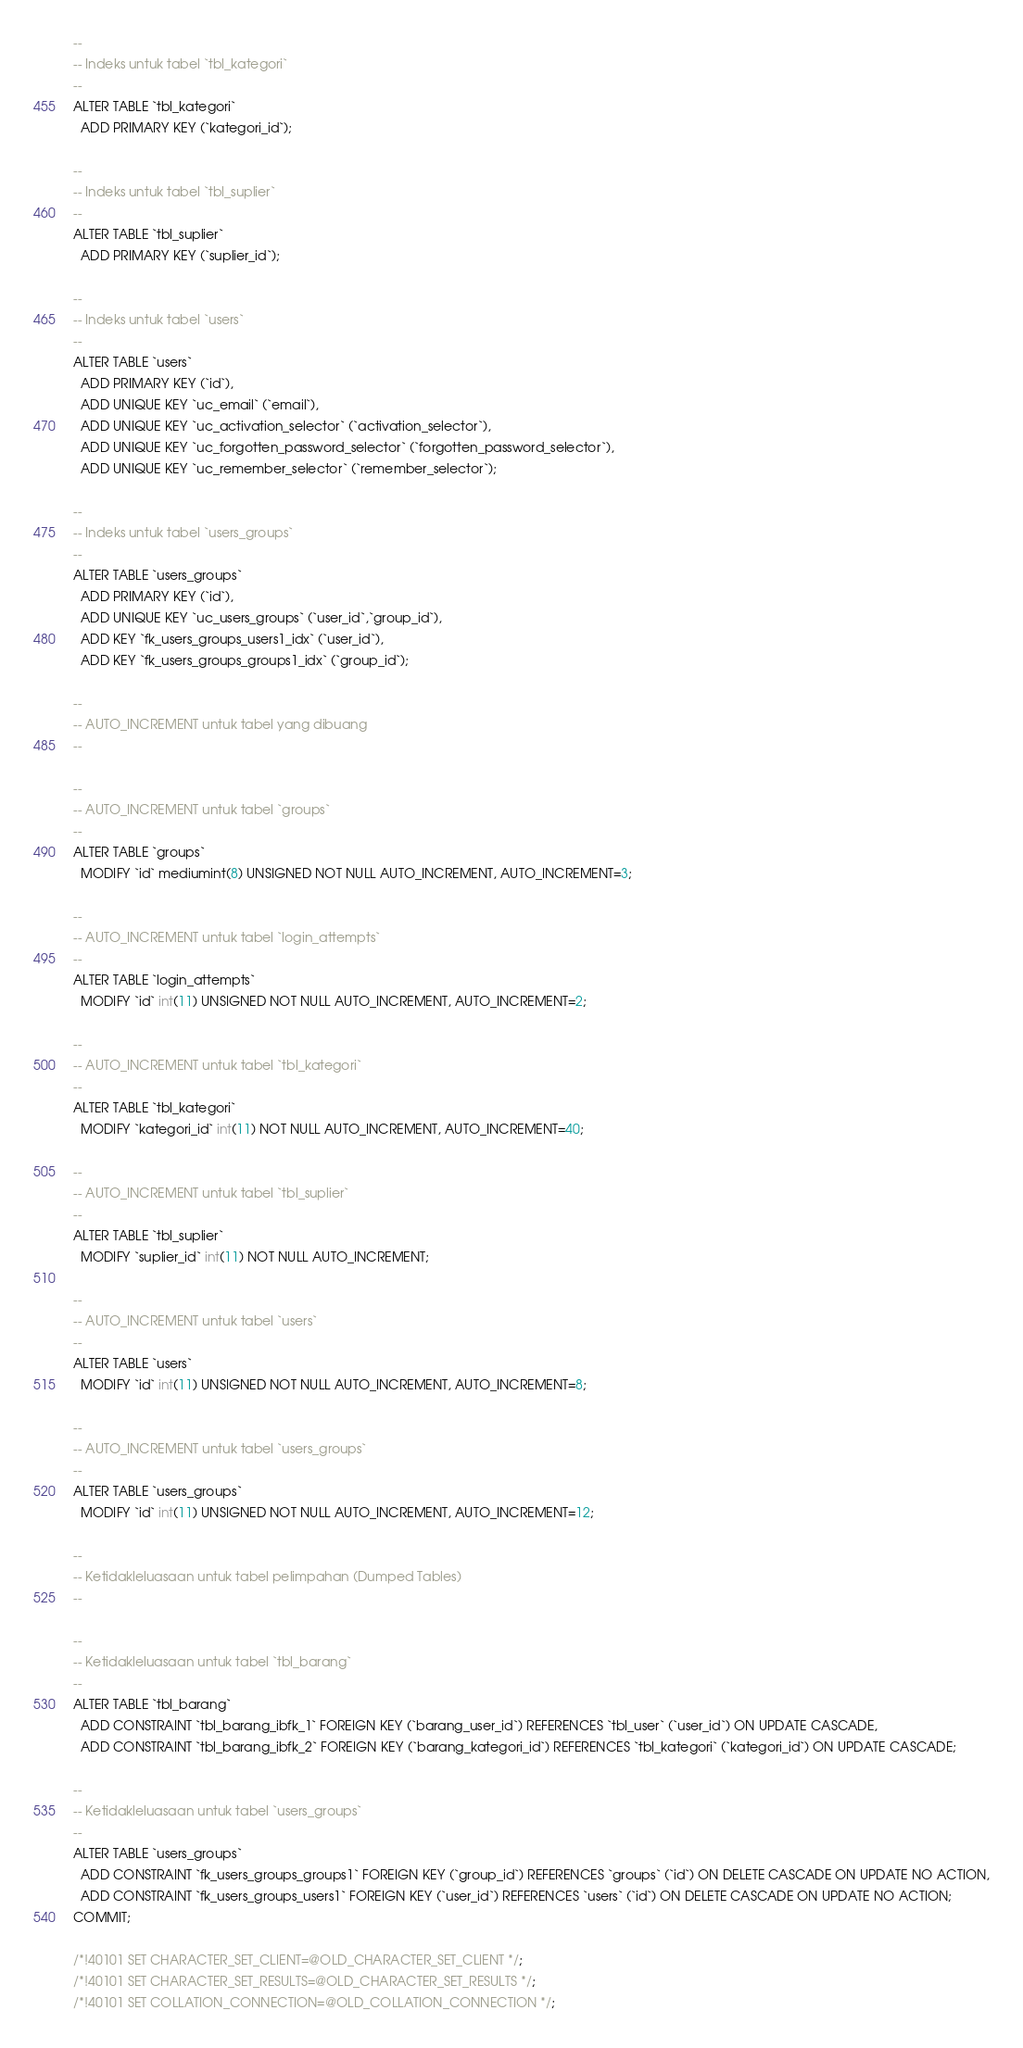Convert code to text. <code><loc_0><loc_0><loc_500><loc_500><_SQL_>
--
-- Indeks untuk tabel `tbl_kategori`
--
ALTER TABLE `tbl_kategori`
  ADD PRIMARY KEY (`kategori_id`);

--
-- Indeks untuk tabel `tbl_suplier`
--
ALTER TABLE `tbl_suplier`
  ADD PRIMARY KEY (`suplier_id`);

--
-- Indeks untuk tabel `users`
--
ALTER TABLE `users`
  ADD PRIMARY KEY (`id`),
  ADD UNIQUE KEY `uc_email` (`email`),
  ADD UNIQUE KEY `uc_activation_selector` (`activation_selector`),
  ADD UNIQUE KEY `uc_forgotten_password_selector` (`forgotten_password_selector`),
  ADD UNIQUE KEY `uc_remember_selector` (`remember_selector`);

--
-- Indeks untuk tabel `users_groups`
--
ALTER TABLE `users_groups`
  ADD PRIMARY KEY (`id`),
  ADD UNIQUE KEY `uc_users_groups` (`user_id`,`group_id`),
  ADD KEY `fk_users_groups_users1_idx` (`user_id`),
  ADD KEY `fk_users_groups_groups1_idx` (`group_id`);

--
-- AUTO_INCREMENT untuk tabel yang dibuang
--

--
-- AUTO_INCREMENT untuk tabel `groups`
--
ALTER TABLE `groups`
  MODIFY `id` mediumint(8) UNSIGNED NOT NULL AUTO_INCREMENT, AUTO_INCREMENT=3;

--
-- AUTO_INCREMENT untuk tabel `login_attempts`
--
ALTER TABLE `login_attempts`
  MODIFY `id` int(11) UNSIGNED NOT NULL AUTO_INCREMENT, AUTO_INCREMENT=2;

--
-- AUTO_INCREMENT untuk tabel `tbl_kategori`
--
ALTER TABLE `tbl_kategori`
  MODIFY `kategori_id` int(11) NOT NULL AUTO_INCREMENT, AUTO_INCREMENT=40;

--
-- AUTO_INCREMENT untuk tabel `tbl_suplier`
--
ALTER TABLE `tbl_suplier`
  MODIFY `suplier_id` int(11) NOT NULL AUTO_INCREMENT;

--
-- AUTO_INCREMENT untuk tabel `users`
--
ALTER TABLE `users`
  MODIFY `id` int(11) UNSIGNED NOT NULL AUTO_INCREMENT, AUTO_INCREMENT=8;

--
-- AUTO_INCREMENT untuk tabel `users_groups`
--
ALTER TABLE `users_groups`
  MODIFY `id` int(11) UNSIGNED NOT NULL AUTO_INCREMENT, AUTO_INCREMENT=12;

--
-- Ketidakleluasaan untuk tabel pelimpahan (Dumped Tables)
--

--
-- Ketidakleluasaan untuk tabel `tbl_barang`
--
ALTER TABLE `tbl_barang`
  ADD CONSTRAINT `tbl_barang_ibfk_1` FOREIGN KEY (`barang_user_id`) REFERENCES `tbl_user` (`user_id`) ON UPDATE CASCADE,
  ADD CONSTRAINT `tbl_barang_ibfk_2` FOREIGN KEY (`barang_kategori_id`) REFERENCES `tbl_kategori` (`kategori_id`) ON UPDATE CASCADE;

--
-- Ketidakleluasaan untuk tabel `users_groups`
--
ALTER TABLE `users_groups`
  ADD CONSTRAINT `fk_users_groups_groups1` FOREIGN KEY (`group_id`) REFERENCES `groups` (`id`) ON DELETE CASCADE ON UPDATE NO ACTION,
  ADD CONSTRAINT `fk_users_groups_users1` FOREIGN KEY (`user_id`) REFERENCES `users` (`id`) ON DELETE CASCADE ON UPDATE NO ACTION;
COMMIT;

/*!40101 SET CHARACTER_SET_CLIENT=@OLD_CHARACTER_SET_CLIENT */;
/*!40101 SET CHARACTER_SET_RESULTS=@OLD_CHARACTER_SET_RESULTS */;
/*!40101 SET COLLATION_CONNECTION=@OLD_COLLATION_CONNECTION */;
</code> 